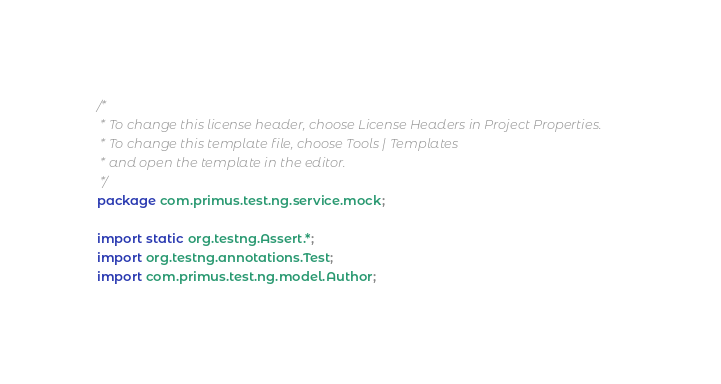<code> <loc_0><loc_0><loc_500><loc_500><_Java_>/*
 * To change this license header, choose License Headers in Project Properties.
 * To change this template file, choose Tools | Templates
 * and open the template in the editor.
 */
package com.primus.test.ng.service.mock;

import static org.testng.Assert.*;
import org.testng.annotations.Test;
import com.primus.test.ng.model.Author;</code> 